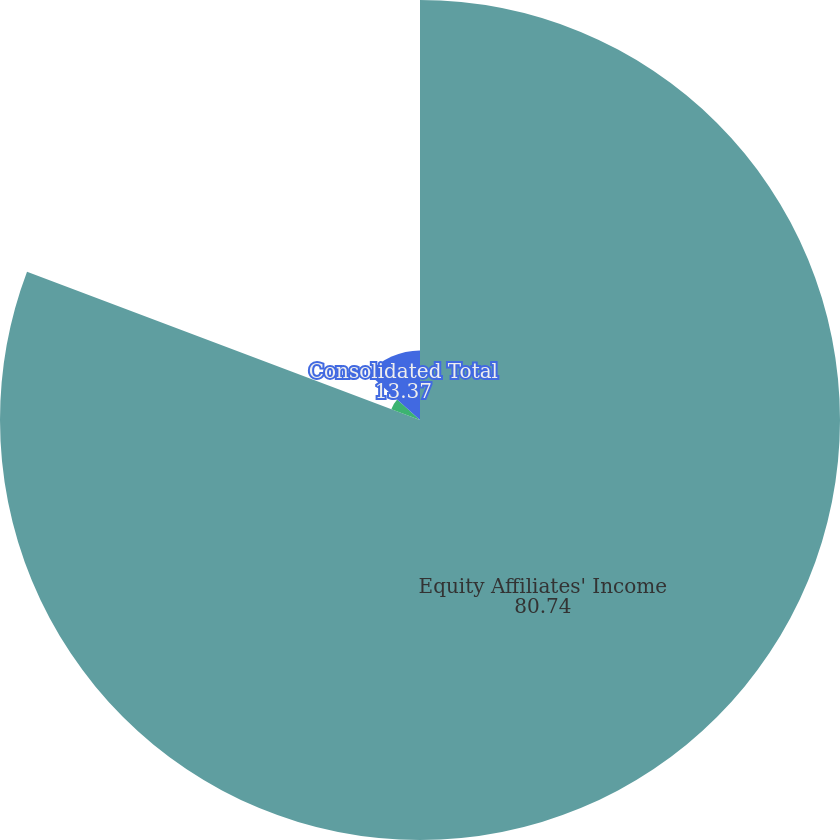Convert chart to OTSL. <chart><loc_0><loc_0><loc_500><loc_500><pie_chart><fcel>Equity Affiliates' Income<fcel>Segment total<fcel>Consolidated Total<nl><fcel>80.74%<fcel>5.89%<fcel>13.37%<nl></chart> 